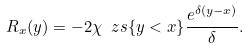Convert formula to latex. <formula><loc_0><loc_0><loc_500><loc_500>R _ { x } ( y ) = - 2 \chi \ z s { \{ y < x \} } \frac { e ^ { \delta ( y - x ) } } { \delta } .</formula> 